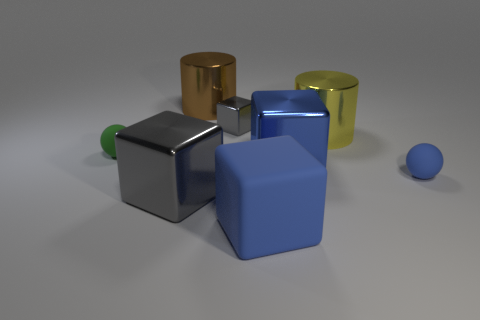How many large gray things have the same shape as the small gray shiny thing? Upon review of the image, there appears to be one large gray object that has the same cube shape as the small gray shiny object. 